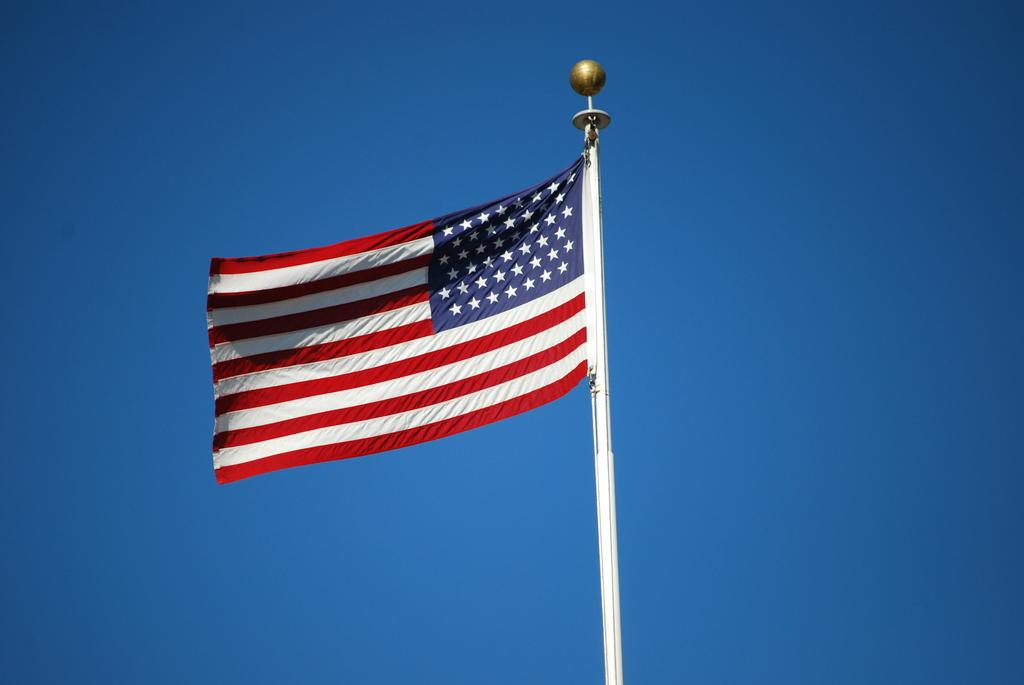What is the main object in the image? There is a pole in the image. What is attached to the pole? There is a flag on the pole. What can be seen in the background of the image? The sky is visible in the background of the image. How many crates are stacked next to the pole in the image? There are no crates present in the image. What type of joke is being told by the flag in the image? The flag is not telling a joke; it is simply a flag attached to a pole. 